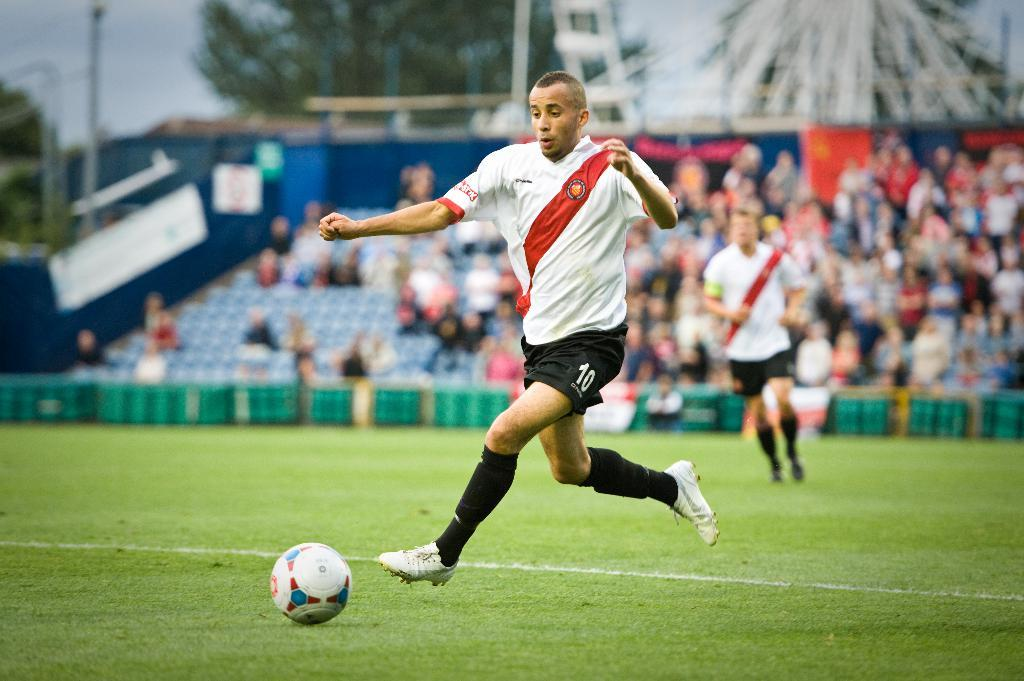<image>
Give a short and clear explanation of the subsequent image. A man is about to kick a soccer ball and has the number 10 on his shorts. 